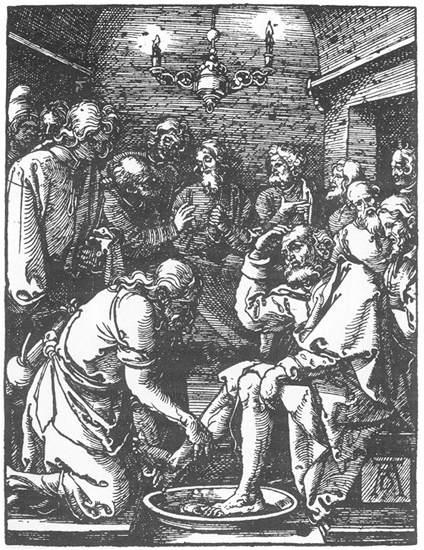What historical or religious event might this illustration be depicting? This illustration likely represents the biblical scene of Jesus washing the feet of his disciples, an event described in the Gospel of John. This act symbolizes humility and servitude, underscoring important themes in Christian teachings. The setting, attire, and the reverent atmosphere all align with this interpretation. Can you describe the expressions and body language of the people in the image? The expressions and body language of the individuals in the image convey a deep sense of solemnity and reverence. The man kneeling to wash the feet is depicted with a humble and focused demeanor, ensuring meticulous attention to the task. The observer's faces reflect contemplation, awe, and respect. Their postures, with slight bows and attentively directed gazes towards the central act, emphasize the significance of the moment. Such details highlight the profound impact of this event on all present. 